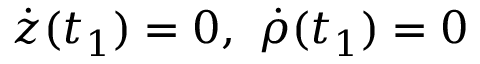<formula> <loc_0><loc_0><loc_500><loc_500>\dot { z } ( t _ { 1 } ) = 0 , \ \dot { \rho } ( t _ { 1 } ) = 0</formula> 